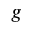Convert formula to latex. <formula><loc_0><loc_0><loc_500><loc_500>g</formula> 